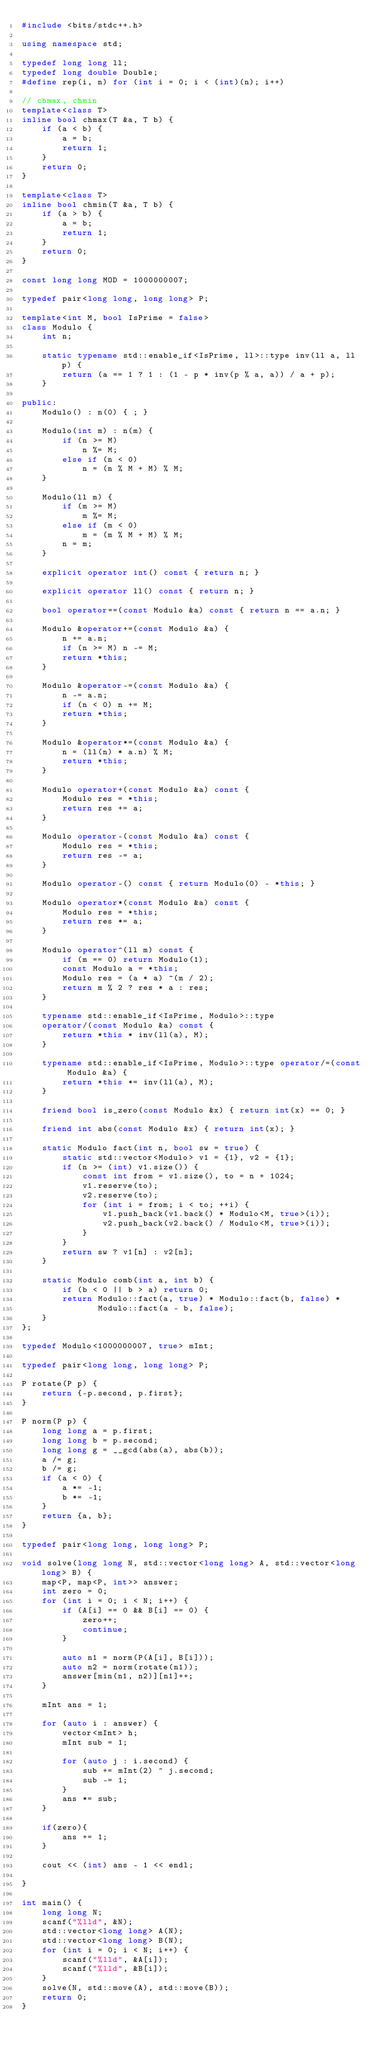<code> <loc_0><loc_0><loc_500><loc_500><_C++_>#include <bits/stdc++.h>

using namespace std;

typedef long long ll;
typedef long double Double;
#define rep(i, n) for (int i = 0; i < (int)(n); i++)

// chmax, chmin
template<class T>
inline bool chmax(T &a, T b) {
    if (a < b) {
        a = b;
        return 1;
    }
    return 0;
}

template<class T>
inline bool chmin(T &a, T b) {
    if (a > b) {
        a = b;
        return 1;
    }
    return 0;
}

const long long MOD = 1000000007;

typedef pair<long long, long long> P;

template<int M, bool IsPrime = false>
class Modulo {
    int n;

    static typename std::enable_if<IsPrime, ll>::type inv(ll a, ll p) {
        return (a == 1 ? 1 : (1 - p * inv(p % a, a)) / a + p);
    }

public:
    Modulo() : n(0) { ; }

    Modulo(int m) : n(m) {
        if (n >= M)
            n %= M;
        else if (n < 0)
            n = (n % M + M) % M;
    }

    Modulo(ll m) {
        if (m >= M)
            m %= M;
        else if (m < 0)
            m = (m % M + M) % M;
        n = m;
    }

    explicit operator int() const { return n; }

    explicit operator ll() const { return n; }

    bool operator==(const Modulo &a) const { return n == a.n; }

    Modulo &operator+=(const Modulo &a) {
        n += a.n;
        if (n >= M) n -= M;
        return *this;
    }

    Modulo &operator-=(const Modulo &a) {
        n -= a.n;
        if (n < 0) n += M;
        return *this;
    }

    Modulo &operator*=(const Modulo &a) {
        n = (ll(n) * a.n) % M;
        return *this;
    }

    Modulo operator+(const Modulo &a) const {
        Modulo res = *this;
        return res += a;
    }

    Modulo operator-(const Modulo &a) const {
        Modulo res = *this;
        return res -= a;
    }

    Modulo operator-() const { return Modulo(0) - *this; }

    Modulo operator*(const Modulo &a) const {
        Modulo res = *this;
        return res *= a;
    }

    Modulo operator^(ll m) const {
        if (m == 0) return Modulo(1);
        const Modulo a = *this;
        Modulo res = (a * a) ^(m / 2);
        return m % 2 ? res * a : res;
    }

    typename std::enable_if<IsPrime, Modulo>::type
    operator/(const Modulo &a) const {
        return *this * inv(ll(a), M);
    }

    typename std::enable_if<IsPrime, Modulo>::type operator/=(const Modulo &a) {
        return *this *= inv(ll(a), M);
    }

    friend bool is_zero(const Modulo &x) { return int(x) == 0; }

    friend int abs(const Modulo &x) { return int(x); }

    static Modulo fact(int n, bool sw = true) {
        static std::vector<Modulo> v1 = {1}, v2 = {1};
        if (n >= (int) v1.size()) {
            const int from = v1.size(), to = n + 1024;
            v1.reserve(to);
            v2.reserve(to);
            for (int i = from; i < to; ++i) {
                v1.push_back(v1.back() * Modulo<M, true>(i));
                v2.push_back(v2.back() / Modulo<M, true>(i));
            }
        }
        return sw ? v1[n] : v2[n];
    }

    static Modulo comb(int a, int b) {
        if (b < 0 || b > a) return 0;
        return Modulo::fact(a, true) * Modulo::fact(b, false) *
               Modulo::fact(a - b, false);
    }
};

typedef Modulo<1000000007, true> mInt;

typedef pair<long long, long long> P;

P rotate(P p) {
    return {-p.second, p.first};
}

P norm(P p) {
    long long a = p.first;
    long long b = p.second;
    long long g = __gcd(abs(a), abs(b));
    a /= g;
    b /= g;
    if (a < 0) {
        a *= -1;
        b *= -1;
    }
    return {a, b};
}

typedef pair<long long, long long> P;

void solve(long long N, std::vector<long long> A, std::vector<long long> B) {
    map<P, map<P, int>> answer;
    int zero = 0;
    for (int i = 0; i < N; i++) {
        if (A[i] == 0 && B[i] == 0) {
            zero++;
            continue;
        }

        auto n1 = norm(P(A[i], B[i]));
        auto n2 = norm(rotate(n1));
        answer[min(n1, n2)][n1]++;
    }

    mInt ans = 1;

    for (auto i : answer) {
        vector<mInt> h;
        mInt sub = 1;

        for (auto j : i.second) {
            sub += mInt(2) ^ j.second;
            sub -= 1;
        }
        ans *= sub;
    }

    if(zero){
        ans += 1;
    }

    cout << (int) ans - 1 << endl;

}

int main() {
    long long N;
    scanf("%lld", &N);
    std::vector<long long> A(N);
    std::vector<long long> B(N);
    for (int i = 0; i < N; i++) {
        scanf("%lld", &A[i]);
        scanf("%lld", &B[i]);
    }
    solve(N, std::move(A), std::move(B));
    return 0;
}
</code> 